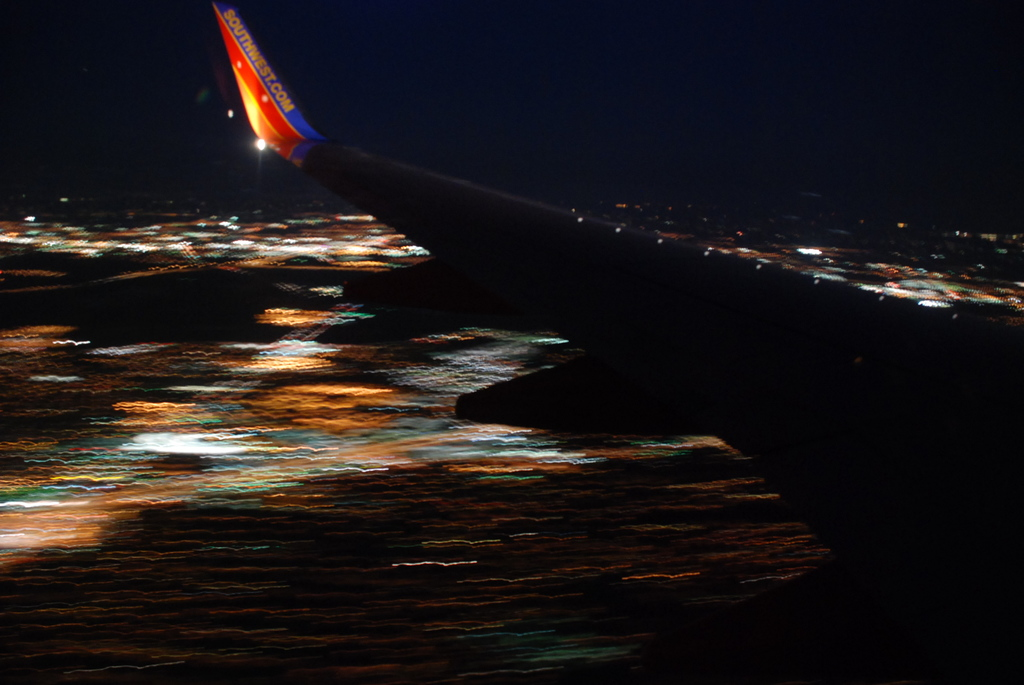What might a traveler be thinking while looking out of the plane window at this scene? A traveler might be feeling a mix of awe and tranquility, observing the city's illuminated arteries weaving through the dark while the airplane glides towards its destination. 